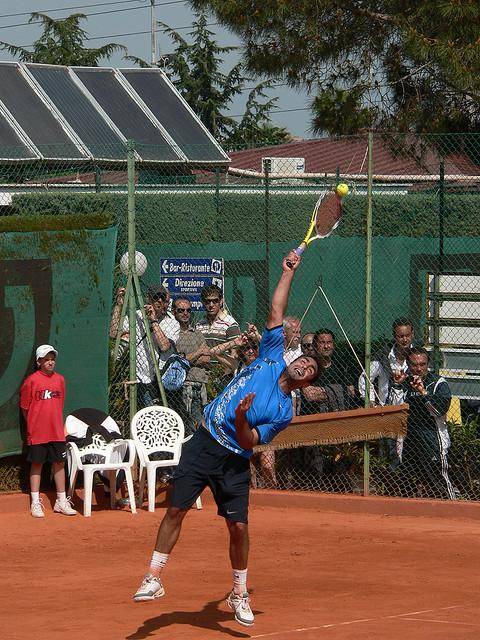Why is his arm so high in the air? Please explain your reasoning. hit ball. A man is reaching up with a tennis racket. 